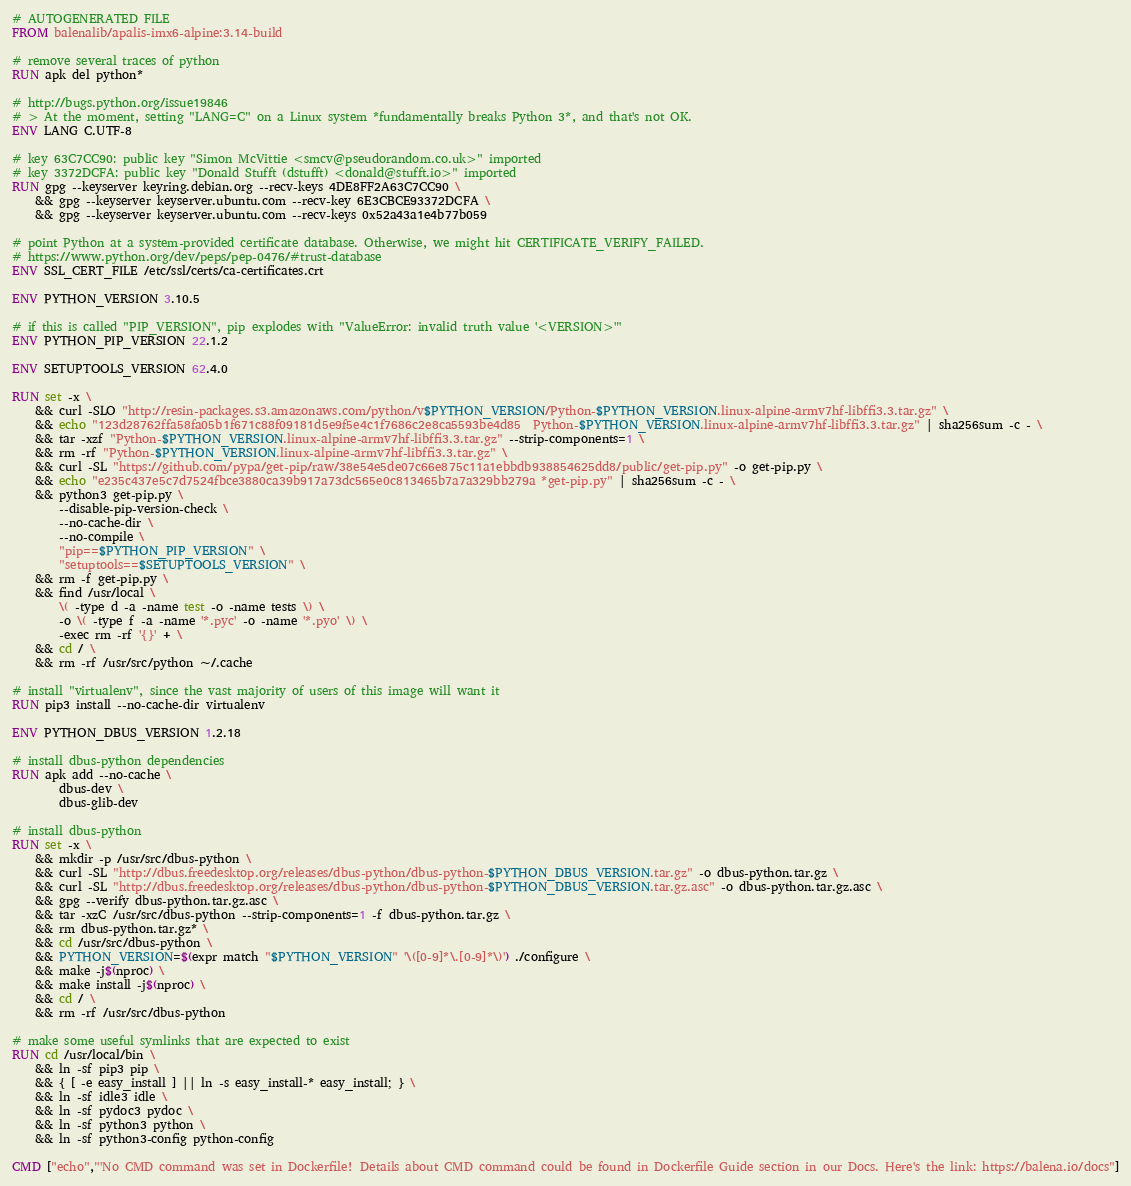<code> <loc_0><loc_0><loc_500><loc_500><_Dockerfile_># AUTOGENERATED FILE
FROM balenalib/apalis-imx6-alpine:3.14-build

# remove several traces of python
RUN apk del python*

# http://bugs.python.org/issue19846
# > At the moment, setting "LANG=C" on a Linux system *fundamentally breaks Python 3*, and that's not OK.
ENV LANG C.UTF-8

# key 63C7CC90: public key "Simon McVittie <smcv@pseudorandom.co.uk>" imported
# key 3372DCFA: public key "Donald Stufft (dstufft) <donald@stufft.io>" imported
RUN gpg --keyserver keyring.debian.org --recv-keys 4DE8FF2A63C7CC90 \
	&& gpg --keyserver keyserver.ubuntu.com --recv-key 6E3CBCE93372DCFA \
	&& gpg --keyserver keyserver.ubuntu.com --recv-keys 0x52a43a1e4b77b059

# point Python at a system-provided certificate database. Otherwise, we might hit CERTIFICATE_VERIFY_FAILED.
# https://www.python.org/dev/peps/pep-0476/#trust-database
ENV SSL_CERT_FILE /etc/ssl/certs/ca-certificates.crt

ENV PYTHON_VERSION 3.10.5

# if this is called "PIP_VERSION", pip explodes with "ValueError: invalid truth value '<VERSION>'"
ENV PYTHON_PIP_VERSION 22.1.2

ENV SETUPTOOLS_VERSION 62.4.0

RUN set -x \
	&& curl -SLO "http://resin-packages.s3.amazonaws.com/python/v$PYTHON_VERSION/Python-$PYTHON_VERSION.linux-alpine-armv7hf-libffi3.3.tar.gz" \
	&& echo "123d28762ffa58fa05b1f671c88f09181d5e9f5e4c1f7686c2e8ca5593be4d85  Python-$PYTHON_VERSION.linux-alpine-armv7hf-libffi3.3.tar.gz" | sha256sum -c - \
	&& tar -xzf "Python-$PYTHON_VERSION.linux-alpine-armv7hf-libffi3.3.tar.gz" --strip-components=1 \
	&& rm -rf "Python-$PYTHON_VERSION.linux-alpine-armv7hf-libffi3.3.tar.gz" \
	&& curl -SL "https://github.com/pypa/get-pip/raw/38e54e5de07c66e875c11a1ebbdb938854625dd8/public/get-pip.py" -o get-pip.py \
    && echo "e235c437e5c7d7524fbce3880ca39b917a73dc565e0c813465b7a7a329bb279a *get-pip.py" | sha256sum -c - \
    && python3 get-pip.py \
        --disable-pip-version-check \
        --no-cache-dir \
        --no-compile \
        "pip==$PYTHON_PIP_VERSION" \
        "setuptools==$SETUPTOOLS_VERSION" \
	&& rm -f get-pip.py \
	&& find /usr/local \
		\( -type d -a -name test -o -name tests \) \
		-o \( -type f -a -name '*.pyc' -o -name '*.pyo' \) \
		-exec rm -rf '{}' + \
	&& cd / \
	&& rm -rf /usr/src/python ~/.cache

# install "virtualenv", since the vast majority of users of this image will want it
RUN pip3 install --no-cache-dir virtualenv

ENV PYTHON_DBUS_VERSION 1.2.18

# install dbus-python dependencies 
RUN apk add --no-cache \
		dbus-dev \
		dbus-glib-dev

# install dbus-python
RUN set -x \
	&& mkdir -p /usr/src/dbus-python \
	&& curl -SL "http://dbus.freedesktop.org/releases/dbus-python/dbus-python-$PYTHON_DBUS_VERSION.tar.gz" -o dbus-python.tar.gz \
	&& curl -SL "http://dbus.freedesktop.org/releases/dbus-python/dbus-python-$PYTHON_DBUS_VERSION.tar.gz.asc" -o dbus-python.tar.gz.asc \
	&& gpg --verify dbus-python.tar.gz.asc \
	&& tar -xzC /usr/src/dbus-python --strip-components=1 -f dbus-python.tar.gz \
	&& rm dbus-python.tar.gz* \
	&& cd /usr/src/dbus-python \
	&& PYTHON_VERSION=$(expr match "$PYTHON_VERSION" '\([0-9]*\.[0-9]*\)') ./configure \
	&& make -j$(nproc) \
	&& make install -j$(nproc) \
	&& cd / \
	&& rm -rf /usr/src/dbus-python

# make some useful symlinks that are expected to exist
RUN cd /usr/local/bin \
	&& ln -sf pip3 pip \
	&& { [ -e easy_install ] || ln -s easy_install-* easy_install; } \
	&& ln -sf idle3 idle \
	&& ln -sf pydoc3 pydoc \
	&& ln -sf python3 python \
	&& ln -sf python3-config python-config

CMD ["echo","'No CMD command was set in Dockerfile! Details about CMD command could be found in Dockerfile Guide section in our Docs. Here's the link: https://balena.io/docs"]
</code> 